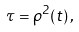<formula> <loc_0><loc_0><loc_500><loc_500>\tau = { \rho ^ { 2 } } ( t ) \, ,</formula> 